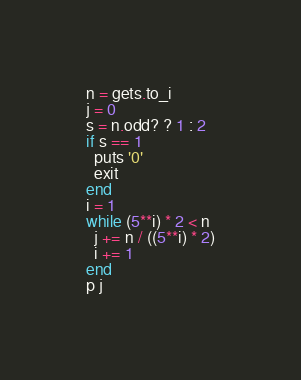Convert code to text. <code><loc_0><loc_0><loc_500><loc_500><_Ruby_>n = gets.to_i
j = 0
s = n.odd? ? 1 : 2
if s == 1
  puts '0'
  exit
end
i = 1
while (5**i) * 2 < n
  j += n / ((5**i) * 2)
  i += 1
end
p j</code> 